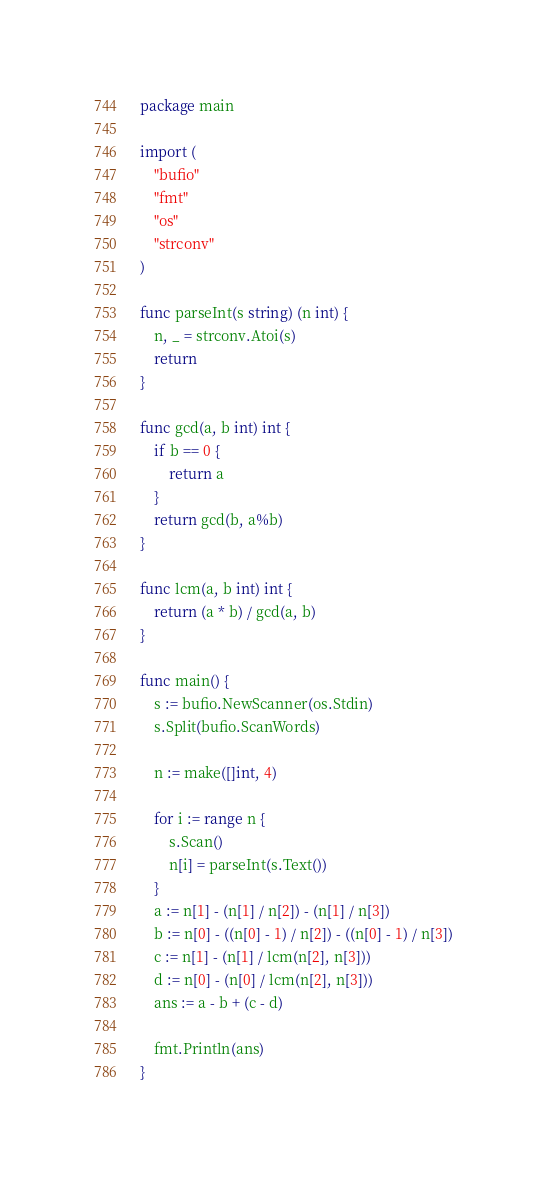<code> <loc_0><loc_0><loc_500><loc_500><_Go_>package main

import (
	"bufio"
	"fmt"
	"os"
	"strconv"
)

func parseInt(s string) (n int) {
	n, _ = strconv.Atoi(s)
	return
}

func gcd(a, b int) int {
	if b == 0 {
		return a
	}
	return gcd(b, a%b)
}

func lcm(a, b int) int {
	return (a * b) / gcd(a, b)
}

func main() {
	s := bufio.NewScanner(os.Stdin)
	s.Split(bufio.ScanWords)

	n := make([]int, 4)

	for i := range n {
		s.Scan()
		n[i] = parseInt(s.Text())
	}
	a := n[1] - (n[1] / n[2]) - (n[1] / n[3])
	b := n[0] - ((n[0] - 1) / n[2]) - ((n[0] - 1) / n[3])
	c := n[1] - (n[1] / lcm(n[2], n[3]))
	d := n[0] - (n[0] / lcm(n[2], n[3]))
	ans := a - b + (c - d)

	fmt.Println(ans)
}
</code> 